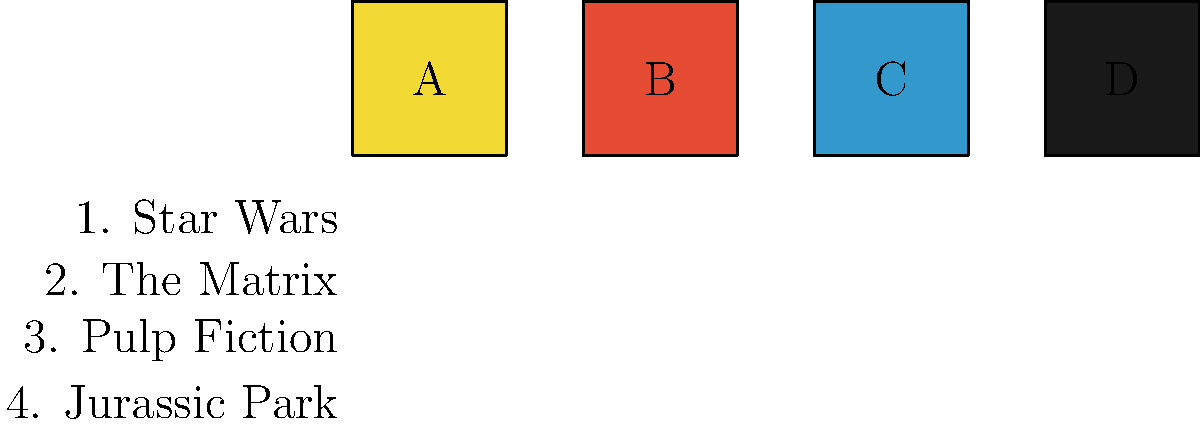Match the color palette above to the iconic movie poster it most closely represents. Which combination of letter and number is correct? To answer this question, we need to analyze the color palettes presented and match them to the iconic movie posters mentioned:

1. Palette A (Yellow): This bright yellow is strongly associated with the "Pulp Fiction" movie poster, which features a vibrant yellow background.

2. Palette B (Red): The dominant red color is reminiscent of the "Jurassic Park" movie poster, which often uses a bold red as its primary color.

3. Palette C (Blue): This shade of blue is commonly associated with "The Matrix" movie posters, reflecting the blue-tinted digital world of the film.

4. Palette D (Black): The stark black color is a signature element of many "Star Wars" movie posters, particularly those featuring Darth Vader or the dark side of the Force.

Matching these observations with the numbered list of movies:

A (Yellow) matches with 3 (Pulp Fiction)
B (Red) matches with 4 (Jurassic Park)
C (Blue) matches with 2 (The Matrix)
D (Black) matches with 1 (Star Wars)

The most iconic and recognizable match from this set is the yellow palette of "Pulp Fiction."
Answer: A3 